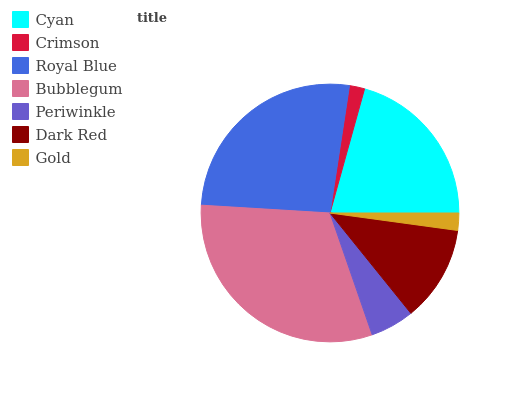Is Crimson the minimum?
Answer yes or no. Yes. Is Bubblegum the maximum?
Answer yes or no. Yes. Is Royal Blue the minimum?
Answer yes or no. No. Is Royal Blue the maximum?
Answer yes or no. No. Is Royal Blue greater than Crimson?
Answer yes or no. Yes. Is Crimson less than Royal Blue?
Answer yes or no. Yes. Is Crimson greater than Royal Blue?
Answer yes or no. No. Is Royal Blue less than Crimson?
Answer yes or no. No. Is Dark Red the high median?
Answer yes or no. Yes. Is Dark Red the low median?
Answer yes or no. Yes. Is Periwinkle the high median?
Answer yes or no. No. Is Crimson the low median?
Answer yes or no. No. 